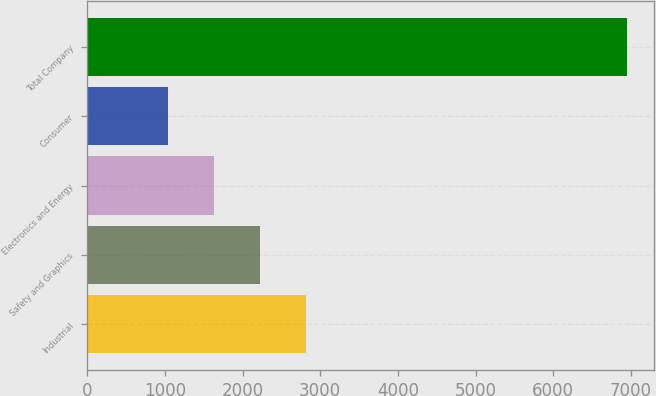Convert chart. <chart><loc_0><loc_0><loc_500><loc_500><bar_chart><fcel>Industrial<fcel>Safety and Graphics<fcel>Electronics and Energy<fcel>Consumer<fcel>Total Company<nl><fcel>2816<fcel>2226<fcel>1636<fcel>1046<fcel>6946<nl></chart> 